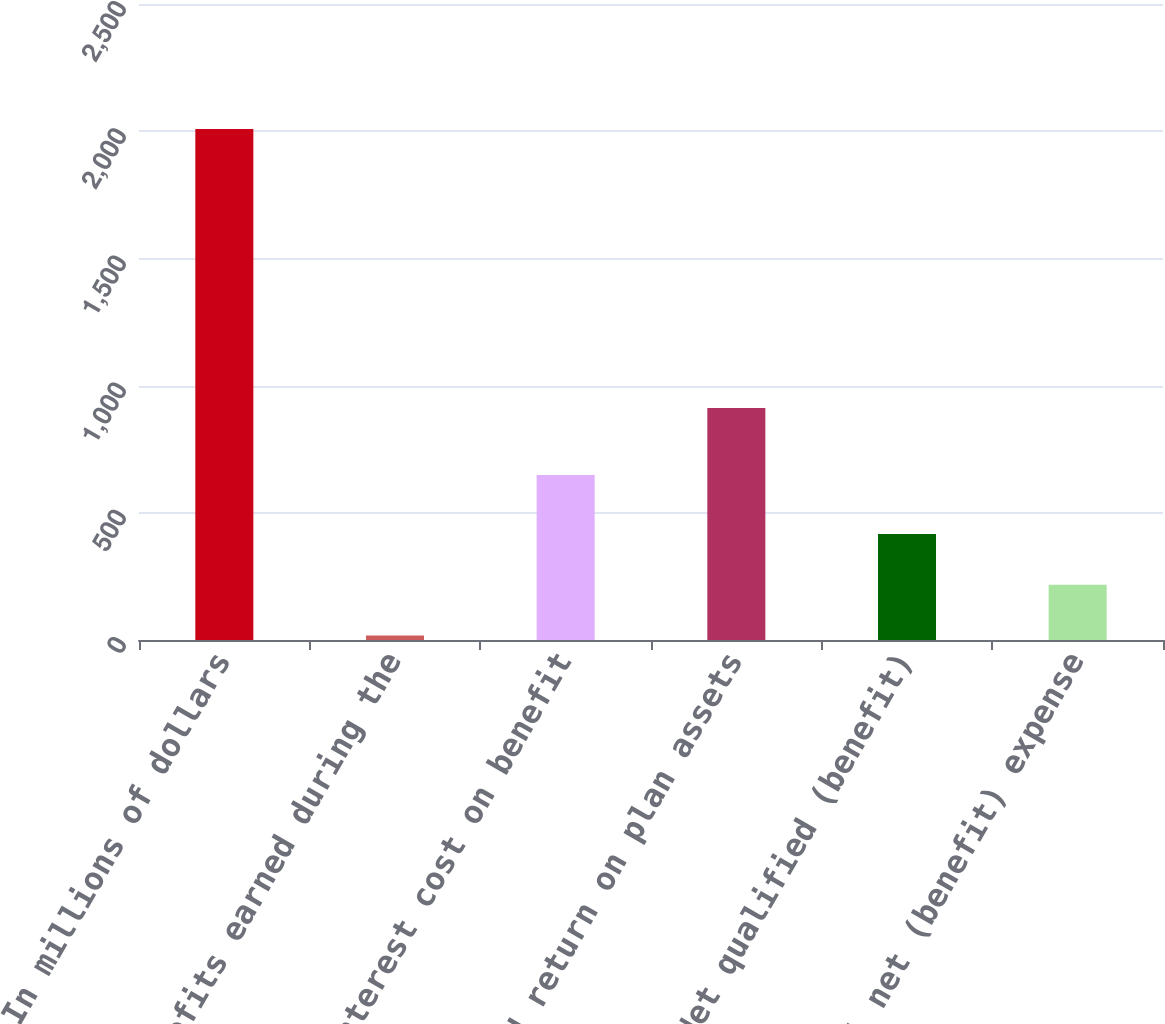Convert chart. <chart><loc_0><loc_0><loc_500><loc_500><bar_chart><fcel>In millions of dollars<fcel>Benefits earned during the<fcel>Interest cost on benefit<fcel>Expected return on plan assets<fcel>Net qualified (benefit)<fcel>Total net (benefit) expense<nl><fcel>2009<fcel>18<fcel>649<fcel>912<fcel>416.2<fcel>217.1<nl></chart> 